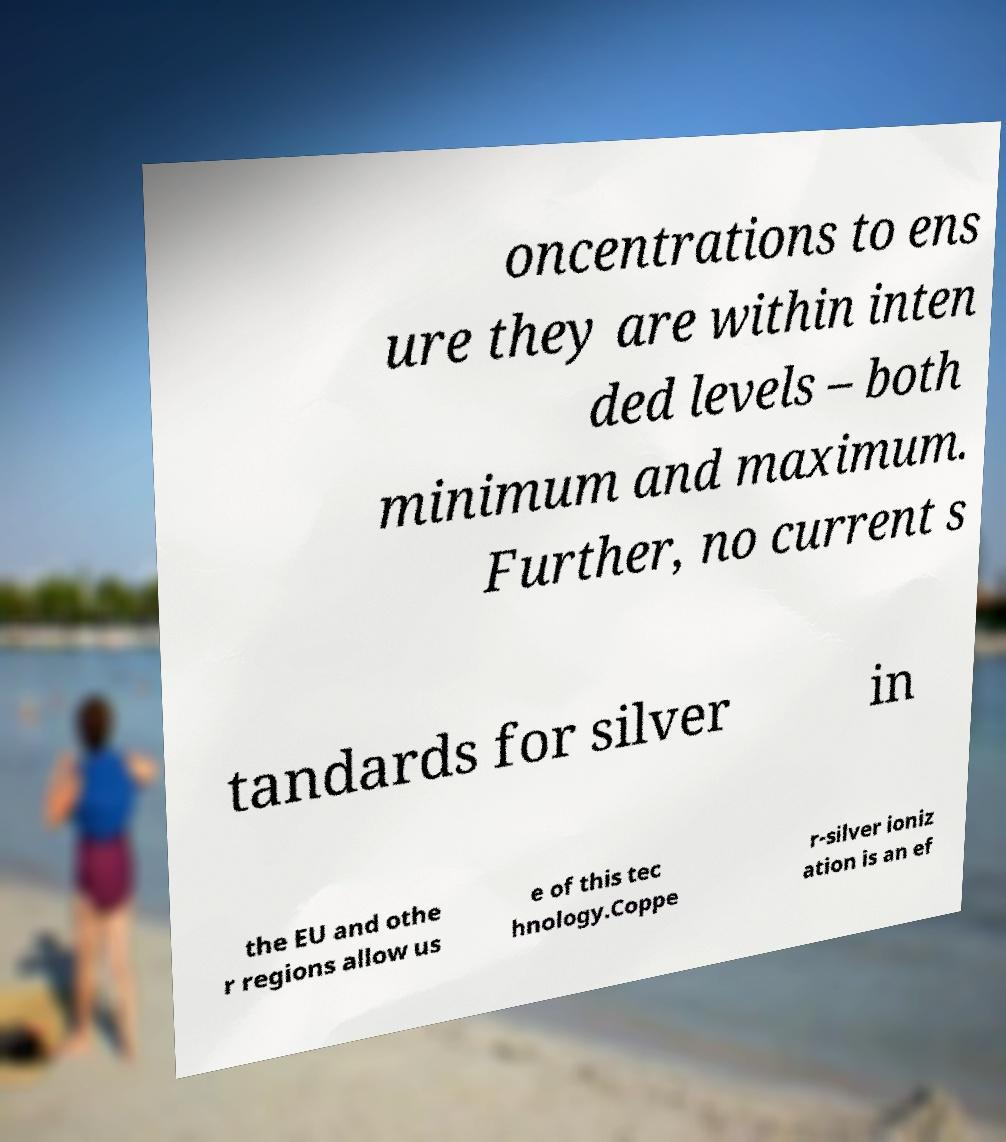Could you assist in decoding the text presented in this image and type it out clearly? oncentrations to ens ure they are within inten ded levels – both minimum and maximum. Further, no current s tandards for silver in the EU and othe r regions allow us e of this tec hnology.Coppe r-silver ioniz ation is an ef 